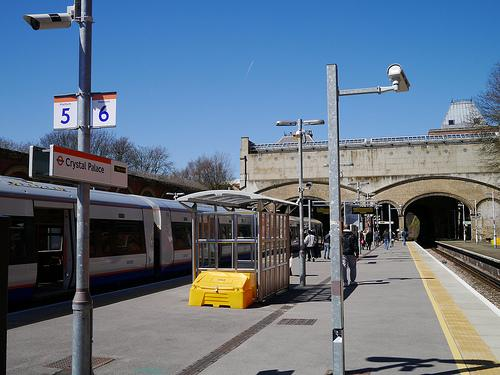Write a short ad for the train service in this image, based on the visual information provided. Welcome aboard our sleek, modern trains, designed to carry you in comfort and style. With our punctual service and well-maintained stations, your journey starts on the right track. Describe one interesting feature of the train station's architecture present in the image. The train station has an arched tunnel where the railway tracks run through, providing a unique and visually appealing entryway for the trains. Which of these colors is present on the sign in the image: black, blue, or green? Blue. What is the primary activity taking place in the image, and where is it happening? People are waiting for a train at a train station platform. In an artistic manner, describe the setting of the image. The sun casts shadows on the ground as trains rest on tracks that disappear into a tunnel, while humans gather in anticipation under a serene, clear sky. Identify the primary mode of transportation shown in the image and its location. The primary mode of transportation is a train, which is on the tracks at a train station. Express the ambiance of the train station in one sentence. The train station emanates a calm yet expectant atmosphere as people wait for their transport. Mention one safety feature present in the image at the train station. The image features a yellow safety line near the train tracks. 